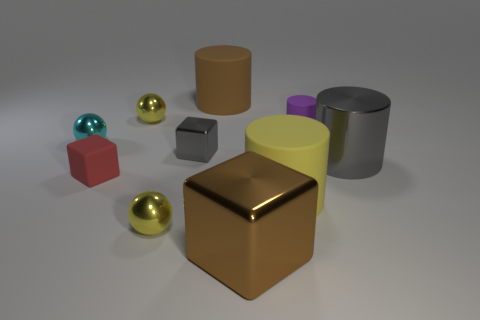Subtract 1 cylinders. How many cylinders are left? 3 Subtract all large yellow cylinders. How many cylinders are left? 3 Subtract all red cylinders. Subtract all blue cubes. How many cylinders are left? 4 Subtract all spheres. How many objects are left? 7 Add 6 metallic blocks. How many metallic blocks exist? 8 Subtract 0 red balls. How many objects are left? 10 Subtract all cylinders. Subtract all metal things. How many objects are left? 0 Add 8 purple things. How many purple things are left? 9 